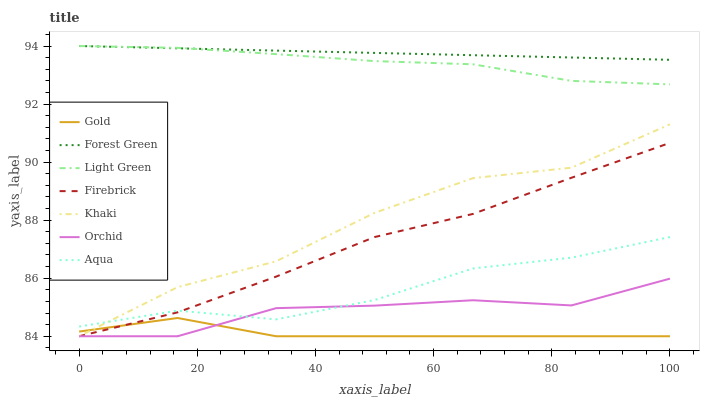Does Gold have the minimum area under the curve?
Answer yes or no. Yes. Does Forest Green have the maximum area under the curve?
Answer yes or no. Yes. Does Firebrick have the minimum area under the curve?
Answer yes or no. No. Does Firebrick have the maximum area under the curve?
Answer yes or no. No. Is Forest Green the smoothest?
Answer yes or no. Yes. Is Khaki the roughest?
Answer yes or no. Yes. Is Gold the smoothest?
Answer yes or no. No. Is Gold the roughest?
Answer yes or no. No. Does Aqua have the lowest value?
Answer yes or no. No. Does Light Green have the highest value?
Answer yes or no. Yes. Does Firebrick have the highest value?
Answer yes or no. No. Is Orchid less than Forest Green?
Answer yes or no. Yes. Is Forest Green greater than Orchid?
Answer yes or no. Yes. Does Firebrick intersect Aqua?
Answer yes or no. Yes. Is Firebrick less than Aqua?
Answer yes or no. No. Is Firebrick greater than Aqua?
Answer yes or no. No. Does Orchid intersect Forest Green?
Answer yes or no. No. 